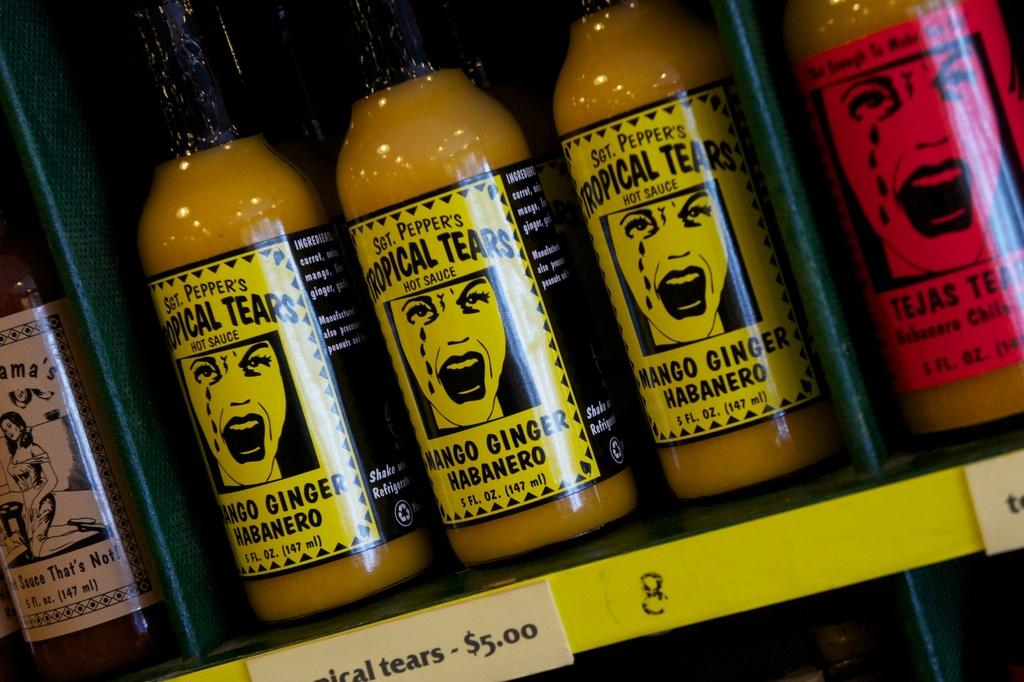What objects are visible in the image? There are bottles in the image. How are the bottles arranged in the image? The bottles are arranged on shelves. What can be found on the shelves besides the bottles? Labels are attached to the shelves. What type of nut can be seen flying with a wing in the image? There is no nut or wing present in the image; it only features bottles arranged on shelves with labels. 